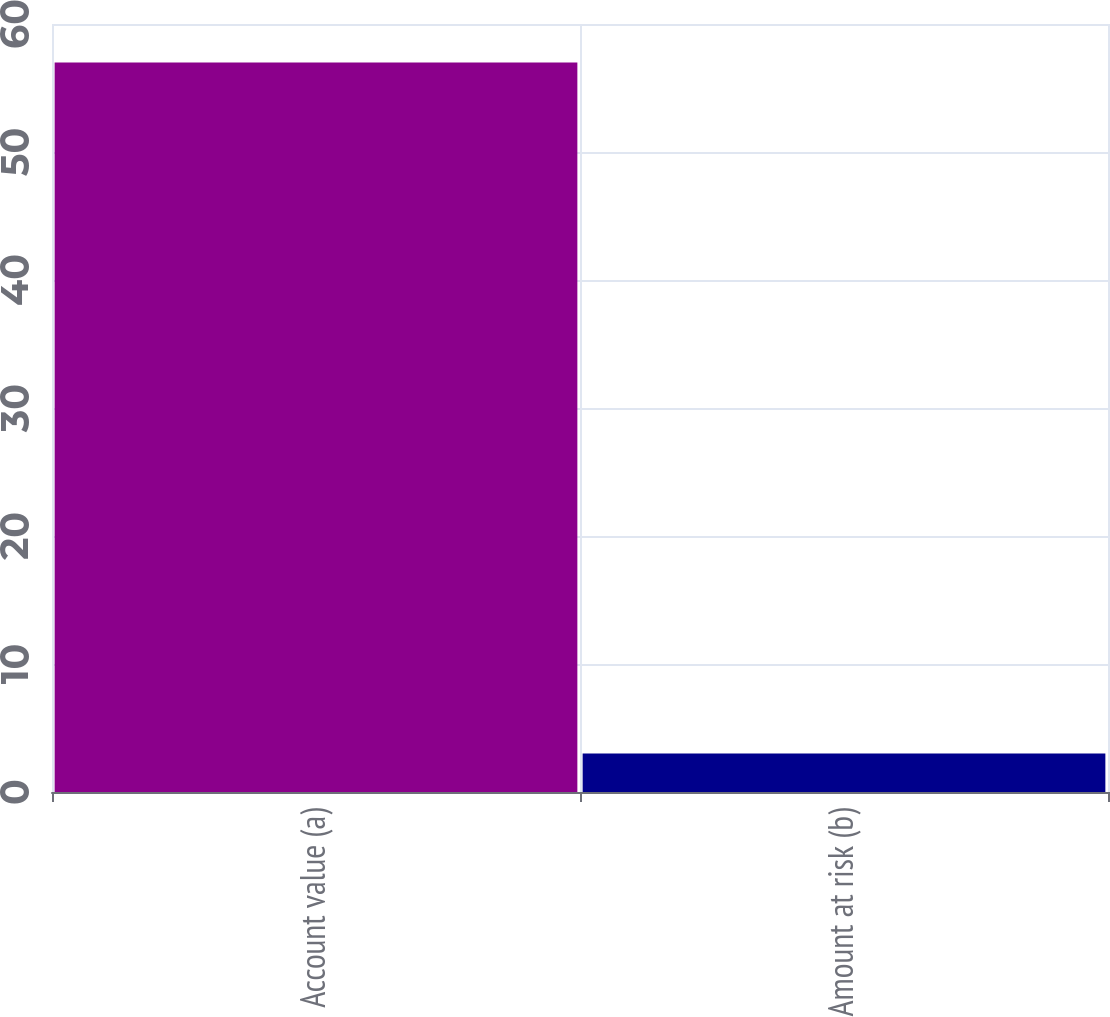Convert chart to OTSL. <chart><loc_0><loc_0><loc_500><loc_500><bar_chart><fcel>Account value (a)<fcel>Amount at risk (b)<nl><fcel>57<fcel>3<nl></chart> 